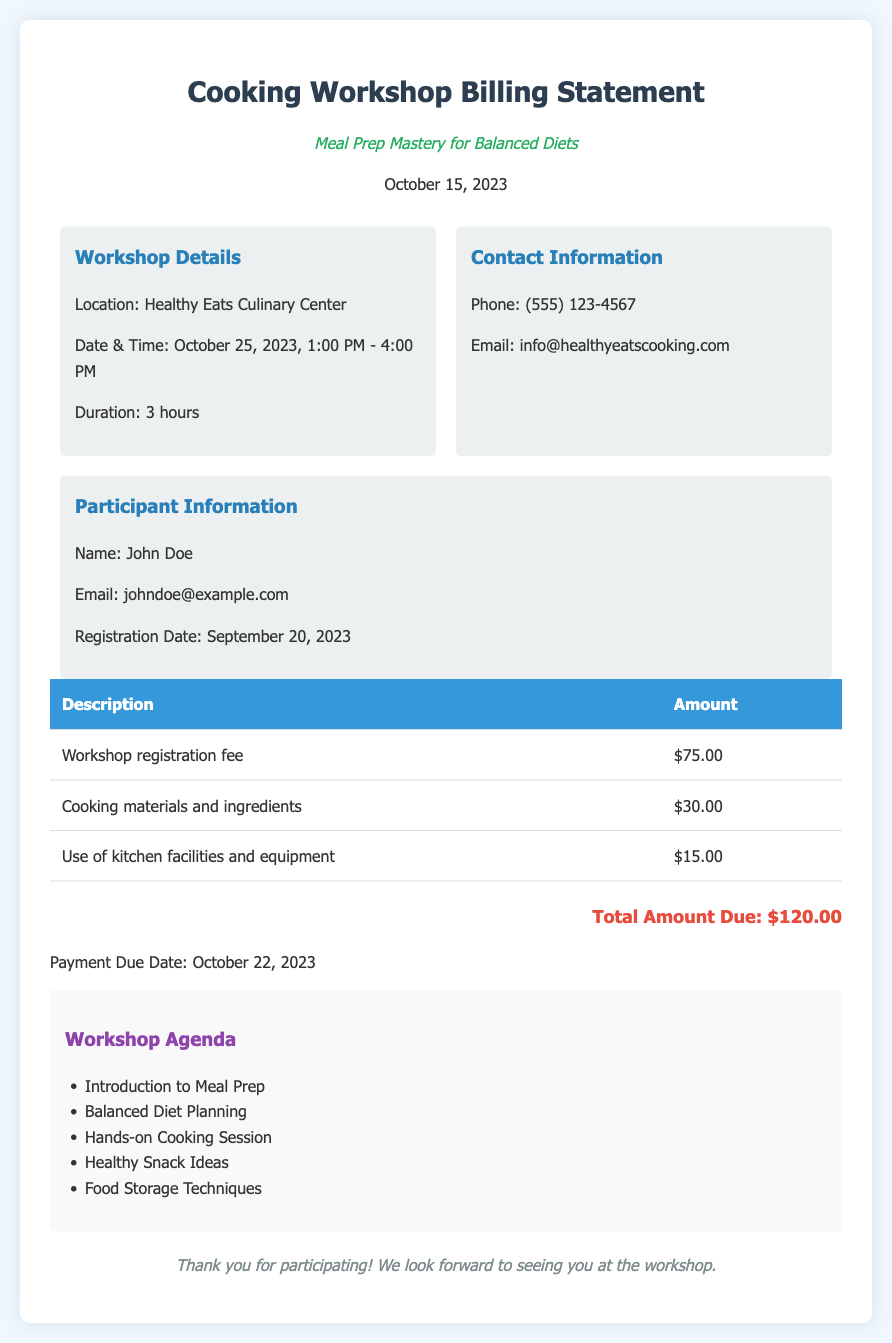What is the title of the workshop? The title is listed prominently as "Meal Prep Mastery for Balanced Diets."
Answer: Meal Prep Mastery for Balanced Diets What is the location of the workshop? The document specifies that the workshop will take place at the "Healthy Eats Culinary Center."
Answer: Healthy Eats Culinary Center What is the total amount due? The total amount due is clearly indicated at the bottom of the billing statement.
Answer: $120.00 When is the payment due date? The payment due date is mentioned in the billing statement as October 22, 2023.
Answer: October 22, 2023 How much is the workshop registration fee? The fee for workshop registration is stated in the document.
Answer: $75.00 What is the duration of the workshop? The duration of the workshop is provided in the details section of the document.
Answer: 3 hours List one item included in the workshop agenda. The agenda includes various topics, of which one is listed in the document.
Answer: Introduction to Meal Prep How many different fees are listed in the billing details? The document outlines three different fees related to the workshop.
Answer: 3 What is the date and time of the workshop? The date and time are provided, allowing the reader to find this information easily.
Answer: October 25, 2023, 1:00 PM - 4:00 PM 